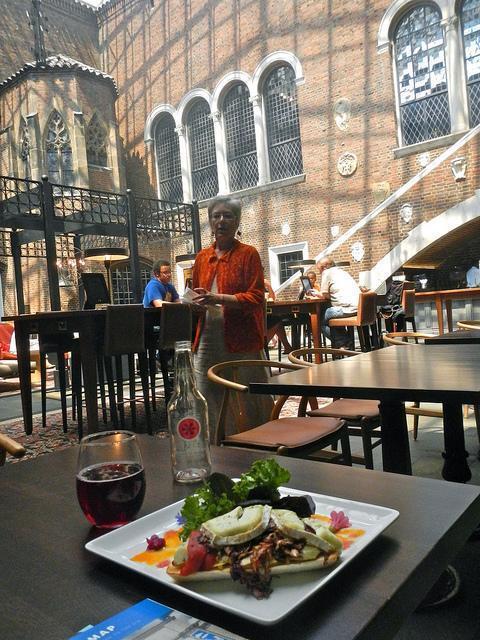How many chairs are there?
Give a very brief answer. 4. How many cups are in the picture?
Give a very brief answer. 1. How many dining tables can be seen?
Give a very brief answer. 2. How many people can you see?
Give a very brief answer. 2. How many dogs are brown?
Give a very brief answer. 0. 